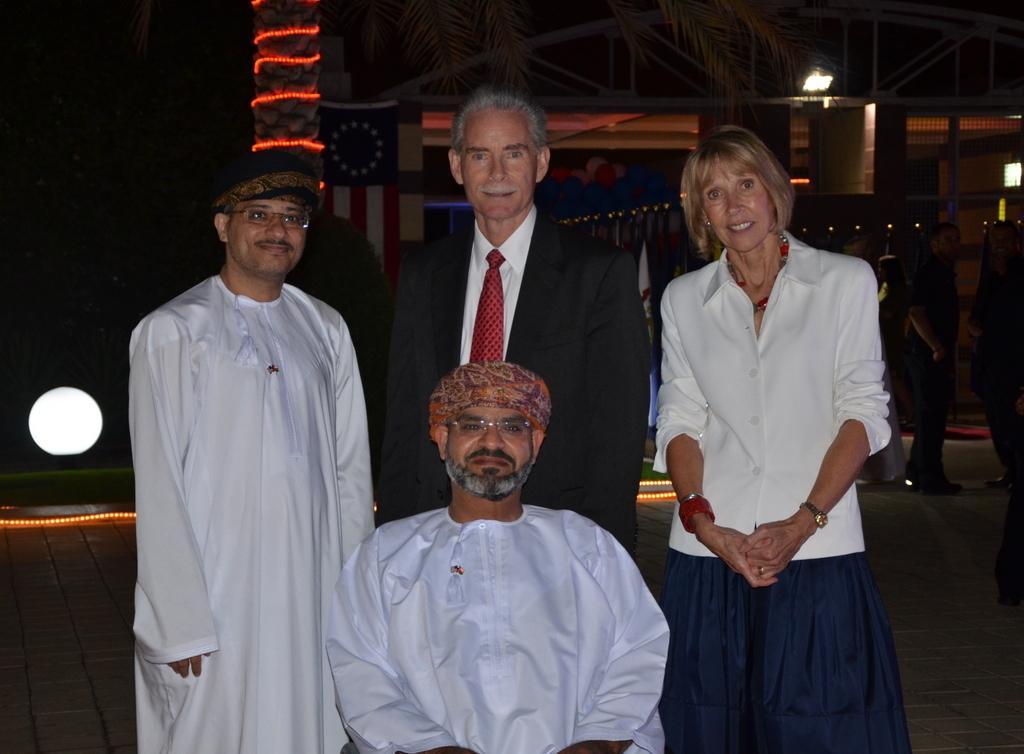Can you describe this image briefly? Here in this picture, in the front we can see a man sitting over a place and behind him we can see three other people standing and we can see all of them are smiling and two of them are wearing spectacles and behind them we can see a store present and we can also see lights present over there and we can see a tree decorated with lights and we can also see other people standing in the far. 